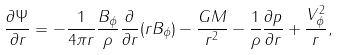<formula> <loc_0><loc_0><loc_500><loc_500>\frac { \partial \Psi } { \partial r } = - \frac { 1 } { 4 \pi r } \frac { B _ { \phi } } { \rho } \frac { \partial } { \partial r } ( r B _ { \phi } ) - \frac { G M } { r ^ { 2 } } - \frac { 1 } { \rho } \frac { \partial p } { \partial r } + \frac { V _ { \phi } ^ { 2 } } { r } ,</formula> 